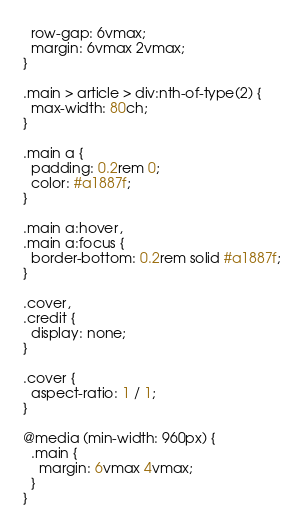Convert code to text. <code><loc_0><loc_0><loc_500><loc_500><_CSS_>  row-gap: 6vmax;
  margin: 6vmax 2vmax;
}

.main > article > div:nth-of-type(2) {
  max-width: 80ch;
}

.main a {
  padding: 0.2rem 0;
  color: #a1887f;
}

.main a:hover,
.main a:focus {
  border-bottom: 0.2rem solid #a1887f;
}

.cover,
.credit {
  display: none;
}

.cover {
  aspect-ratio: 1 / 1;
}

@media (min-width: 960px) {
  .main {
    margin: 6vmax 4vmax;
  }
}
</code> 